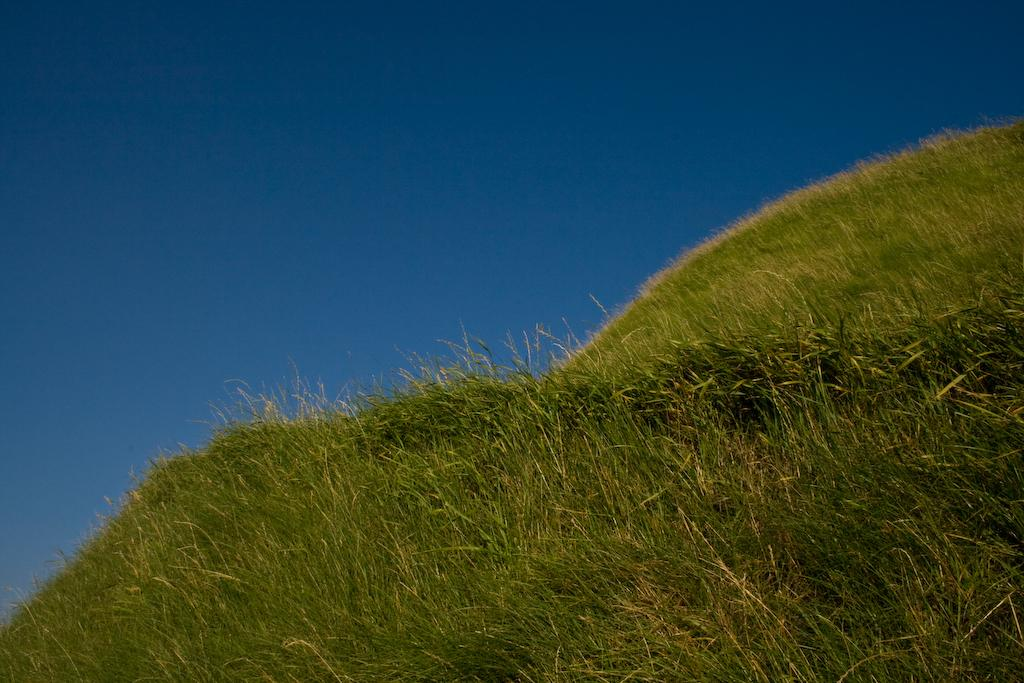What type of vegetation is present in the image? The image contains green grass. What part of the natural environment is visible in the image? The sky is visible at the top of the image. What letter is written on the cherry in the image? There is no cherry present in the image, and therefore no letter can be written on it. 